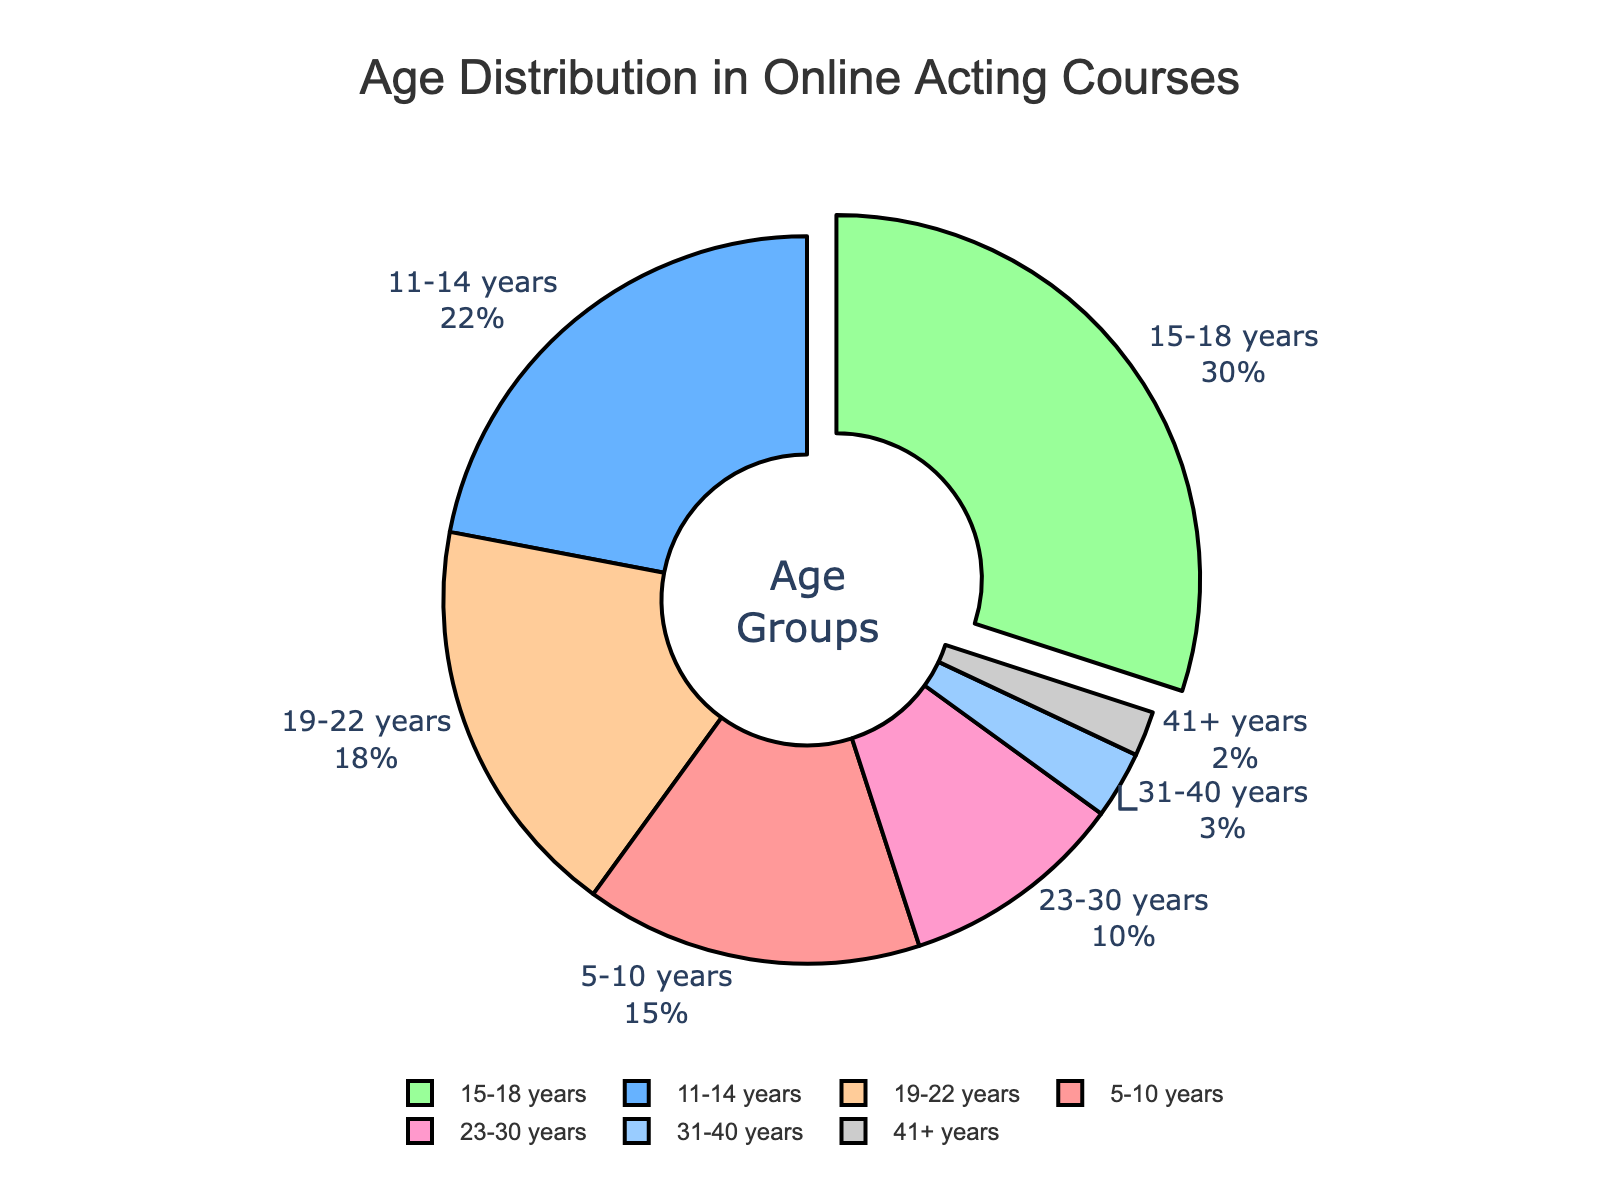Which age group has the highest representation in online acting courses? We can see that the "15-18 years" age group occupies the largest section of the donut chart, indicating they have the highest percentage.
Answer: 15-18 years What is the combined percentage of participants aged 23 years and above? Add the percentages for "23-30 years," "31-40 years," and "41+ years": 10% + 3% + 2% = 15%.
Answer: 15% How much more represented is the "15-18 years" group compared to the "19-22 years" group? Subtract the "19-22 years" percentage from the "15-18 years" percentage: 30% - 18% = 12%.
Answer: 12% Which color represents the "11-14 years" age group? The "11-14 years" section of the donut chart is colored in a medium blue shade.
Answer: Blue What is the percentage representation of the two youngest age groups combined? Add the percentages for "5-10 years" and "11-14 years": 15% + 22% = 37%.
Answer: 37% Compare the representation of "5-10 years" and "23-30 years" age groups. Which one is higher and by how much? The "23-30 years" group is represented by 10%, while the "5-10 years" group is 15%. Subtract the two: 15% - 10% = 5%.
Answer: 5% higher for 5-10 years What is the difference between the highest and lowest represented age groups, and which are they? The highest is "15-18 years" (30%) and the lowest is "41+ years" (2%). Subtract the lowest from the highest: 30% - 2% = 28%.
Answer: 28%, 15-18 years and 41+ years If the total number of participants is 200, how many participants are in the "19-22 years" age group? Calculate 18% of 200: 0.18 * 200 = 36 participants.
Answer: 36 What percentage do the age groups under 15 years old contribute to the overall participation? Add the percentages of "5-10 years" and "11-14 years" groups combined: 15% + 22% = 37%.
Answer: 37% Which age groups together make up over 50% of the total participants? Add the top 3 highest percentages in descending order until the sum exceeds 50%. "15-18 years" (30%) + "11-14 years" (22%) = 52%.
Answer: 15-18 years, 11-14 years 